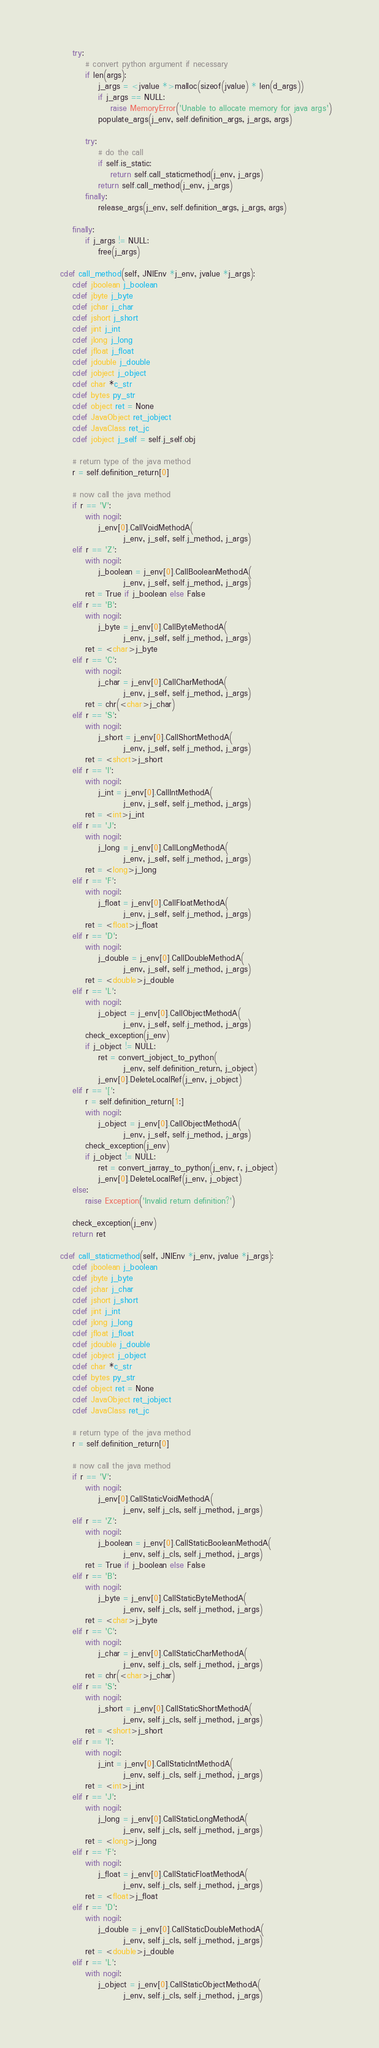Convert code to text. <code><loc_0><loc_0><loc_500><loc_500><_Cython_>
        try:
            # convert python argument if necessary
            if len(args):
                j_args = <jvalue *>malloc(sizeof(jvalue) * len(d_args))
                if j_args == NULL:
                    raise MemoryError('Unable to allocate memory for java args')
                populate_args(j_env, self.definition_args, j_args, args)

            try:
                # do the call
                if self.is_static:
                    return self.call_staticmethod(j_env, j_args)
                return self.call_method(j_env, j_args)
            finally:
                release_args(j_env, self.definition_args, j_args, args)

        finally:
            if j_args != NULL:
                free(j_args)

    cdef call_method(self, JNIEnv *j_env, jvalue *j_args):
        cdef jboolean j_boolean
        cdef jbyte j_byte
        cdef jchar j_char
        cdef jshort j_short
        cdef jint j_int
        cdef jlong j_long
        cdef jfloat j_float
        cdef jdouble j_double
        cdef jobject j_object
        cdef char *c_str
        cdef bytes py_str
        cdef object ret = None
        cdef JavaObject ret_jobject
        cdef JavaClass ret_jc
        cdef jobject j_self = self.j_self.obj

        # return type of the java method
        r = self.definition_return[0]

        # now call the java method
        if r == 'V':
            with nogil:
                j_env[0].CallVoidMethodA(
                        j_env, j_self, self.j_method, j_args)
        elif r == 'Z':
            with nogil:
                j_boolean = j_env[0].CallBooleanMethodA(
                        j_env, j_self, self.j_method, j_args)
            ret = True if j_boolean else False
        elif r == 'B':
            with nogil:
                j_byte = j_env[0].CallByteMethodA(
                        j_env, j_self, self.j_method, j_args)
            ret = <char>j_byte
        elif r == 'C':
            with nogil:
                j_char = j_env[0].CallCharMethodA(
                        j_env, j_self, self.j_method, j_args)
            ret = chr(<char>j_char)
        elif r == 'S':
            with nogil:
                j_short = j_env[0].CallShortMethodA(
                        j_env, j_self, self.j_method, j_args)
            ret = <short>j_short
        elif r == 'I':
            with nogil:
                j_int = j_env[0].CallIntMethodA(
                        j_env, j_self, self.j_method, j_args)
            ret = <int>j_int
        elif r == 'J':
            with nogil:
                j_long = j_env[0].CallLongMethodA(
                        j_env, j_self, self.j_method, j_args)
            ret = <long>j_long
        elif r == 'F':
            with nogil:
                j_float = j_env[0].CallFloatMethodA(
                        j_env, j_self, self.j_method, j_args)
            ret = <float>j_float
        elif r == 'D':
            with nogil:
                j_double = j_env[0].CallDoubleMethodA(
                        j_env, j_self, self.j_method, j_args)
            ret = <double>j_double
        elif r == 'L':
            with nogil:
                j_object = j_env[0].CallObjectMethodA(
                        j_env, j_self, self.j_method, j_args)
            check_exception(j_env)
            if j_object != NULL:
                ret = convert_jobject_to_python(
                        j_env, self.definition_return, j_object)
                j_env[0].DeleteLocalRef(j_env, j_object)
        elif r == '[':
            r = self.definition_return[1:]
            with nogil:
                j_object = j_env[0].CallObjectMethodA(
                        j_env, j_self, self.j_method, j_args)
            check_exception(j_env)
            if j_object != NULL:
                ret = convert_jarray_to_python(j_env, r, j_object)
                j_env[0].DeleteLocalRef(j_env, j_object)
        else:
            raise Exception('Invalid return definition?')

        check_exception(j_env)
        return ret

    cdef call_staticmethod(self, JNIEnv *j_env, jvalue *j_args):
        cdef jboolean j_boolean
        cdef jbyte j_byte
        cdef jchar j_char
        cdef jshort j_short
        cdef jint j_int
        cdef jlong j_long
        cdef jfloat j_float
        cdef jdouble j_double
        cdef jobject j_object
        cdef char *c_str
        cdef bytes py_str
        cdef object ret = None
        cdef JavaObject ret_jobject
        cdef JavaClass ret_jc

        # return type of the java method
        r = self.definition_return[0]

        # now call the java method
        if r == 'V':
            with nogil:
                j_env[0].CallStaticVoidMethodA(
                        j_env, self.j_cls, self.j_method, j_args)
        elif r == 'Z':
            with nogil:
                j_boolean = j_env[0].CallStaticBooleanMethodA(
                        j_env, self.j_cls, self.j_method, j_args)
            ret = True if j_boolean else False
        elif r == 'B':
            with nogil:
                j_byte = j_env[0].CallStaticByteMethodA(
                        j_env, self.j_cls, self.j_method, j_args)
            ret = <char>j_byte
        elif r == 'C':
            with nogil:
                j_char = j_env[0].CallStaticCharMethodA(
                        j_env, self.j_cls, self.j_method, j_args)
            ret = chr(<char>j_char)
        elif r == 'S':
            with nogil:
                j_short = j_env[0].CallStaticShortMethodA(
                        j_env, self.j_cls, self.j_method, j_args)
            ret = <short>j_short
        elif r == 'I':
            with nogil:
                j_int = j_env[0].CallStaticIntMethodA(
                        j_env, self.j_cls, self.j_method, j_args)
            ret = <int>j_int
        elif r == 'J':
            with nogil:
                j_long = j_env[0].CallStaticLongMethodA(
                        j_env, self.j_cls, self.j_method, j_args)
            ret = <long>j_long
        elif r == 'F':
            with nogil:
                j_float = j_env[0].CallStaticFloatMethodA(
                        j_env, self.j_cls, self.j_method, j_args)
            ret = <float>j_float
        elif r == 'D':
            with nogil:
                j_double = j_env[0].CallStaticDoubleMethodA(
                        j_env, self.j_cls, self.j_method, j_args)
            ret = <double>j_double
        elif r == 'L':
            with nogil:
                j_object = j_env[0].CallStaticObjectMethodA(
                        j_env, self.j_cls, self.j_method, j_args)</code> 